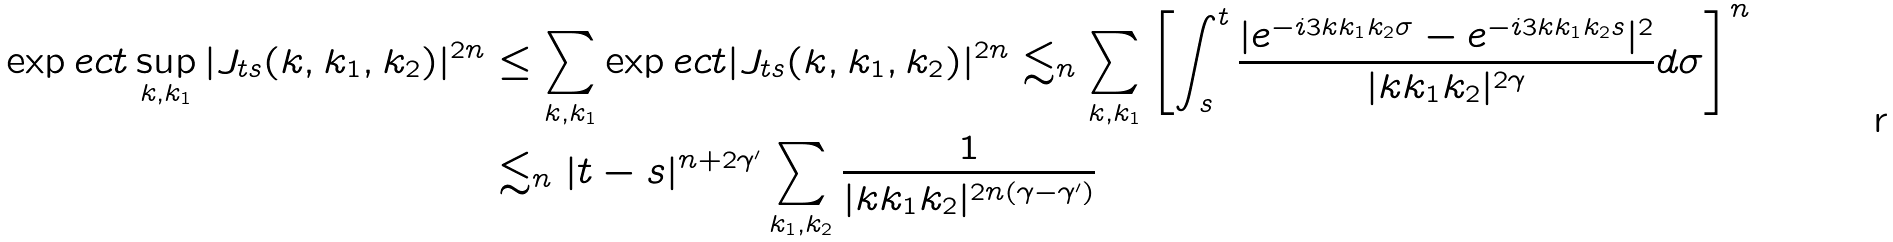<formula> <loc_0><loc_0><loc_500><loc_500>\exp e c t \sup _ { k , k _ { 1 } } | J _ { t s } ( k , k _ { 1 } , k _ { 2 } ) | ^ { 2 n } & \leq \sum _ { k , k _ { 1 } } \exp e c t | J _ { t s } ( k , k _ { 1 } , k _ { 2 } ) | ^ { 2 n } \lesssim _ { n } \sum _ { k , k _ { 1 } } \left [ \int _ { s } ^ { t } \frac { | e ^ { - i 3 k k _ { 1 } k _ { 2 } \sigma } - e ^ { - i 3 k k _ { 1 } k _ { 2 } s } | ^ { 2 } } { | k k _ { 1 } k _ { 2 } | ^ { 2 \gamma } } d \sigma \right ] ^ { n } \\ & \lesssim _ { n } | t - s | ^ { n + 2 \gamma ^ { \prime } } \sum _ { k _ { 1 } , k _ { 2 } } \frac { 1 } { | k k _ { 1 } k _ { 2 } | ^ { 2 n ( \gamma - \gamma ^ { \prime } ) } }</formula> 